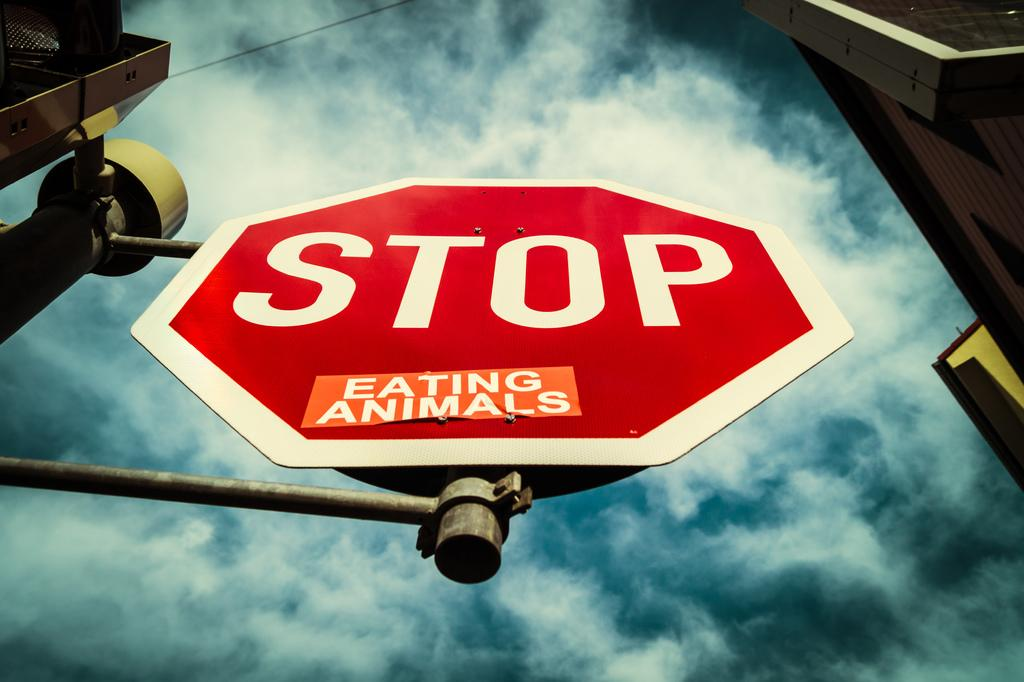<image>
Share a concise interpretation of the image provided. A sticker has been added to a stop sign which protests against the consumption of animals. 